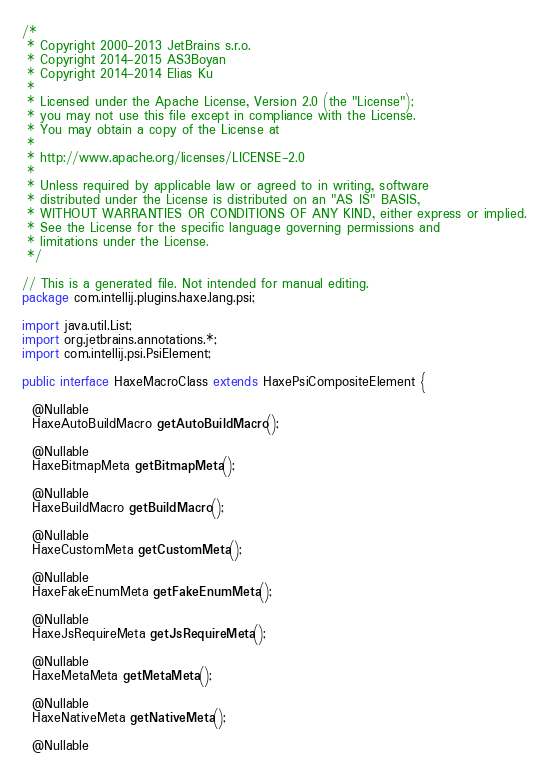<code> <loc_0><loc_0><loc_500><loc_500><_Java_>/*
 * Copyright 2000-2013 JetBrains s.r.o.
 * Copyright 2014-2015 AS3Boyan
 * Copyright 2014-2014 Elias Ku
 *
 * Licensed under the Apache License, Version 2.0 (the "License");
 * you may not use this file except in compliance with the License.
 * You may obtain a copy of the License at
 *
 * http://www.apache.org/licenses/LICENSE-2.0
 *
 * Unless required by applicable law or agreed to in writing, software
 * distributed under the License is distributed on an "AS IS" BASIS,
 * WITHOUT WARRANTIES OR CONDITIONS OF ANY KIND, either express or implied.
 * See the License for the specific language governing permissions and
 * limitations under the License.
 */

// This is a generated file. Not intended for manual editing.
package com.intellij.plugins.haxe.lang.psi;

import java.util.List;
import org.jetbrains.annotations.*;
import com.intellij.psi.PsiElement;

public interface HaxeMacroClass extends HaxePsiCompositeElement {

  @Nullable
  HaxeAutoBuildMacro getAutoBuildMacro();

  @Nullable
  HaxeBitmapMeta getBitmapMeta();

  @Nullable
  HaxeBuildMacro getBuildMacro();

  @Nullable
  HaxeCustomMeta getCustomMeta();

  @Nullable
  HaxeFakeEnumMeta getFakeEnumMeta();

  @Nullable
  HaxeJsRequireMeta getJsRequireMeta();

  @Nullable
  HaxeMetaMeta getMetaMeta();

  @Nullable
  HaxeNativeMeta getNativeMeta();

  @Nullable</code> 